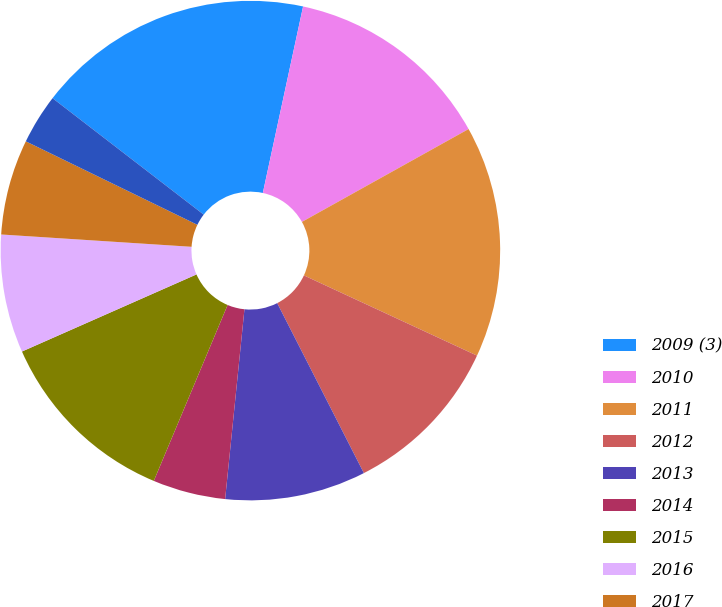Convert chart to OTSL. <chart><loc_0><loc_0><loc_500><loc_500><pie_chart><fcel>2009 (3)<fcel>2010<fcel>2011<fcel>2012<fcel>2013<fcel>2014<fcel>2015<fcel>2016<fcel>2017<fcel>2018<nl><fcel>17.94%<fcel>13.53%<fcel>15.0%<fcel>10.59%<fcel>9.12%<fcel>4.71%<fcel>12.06%<fcel>7.65%<fcel>6.18%<fcel>3.24%<nl></chart> 